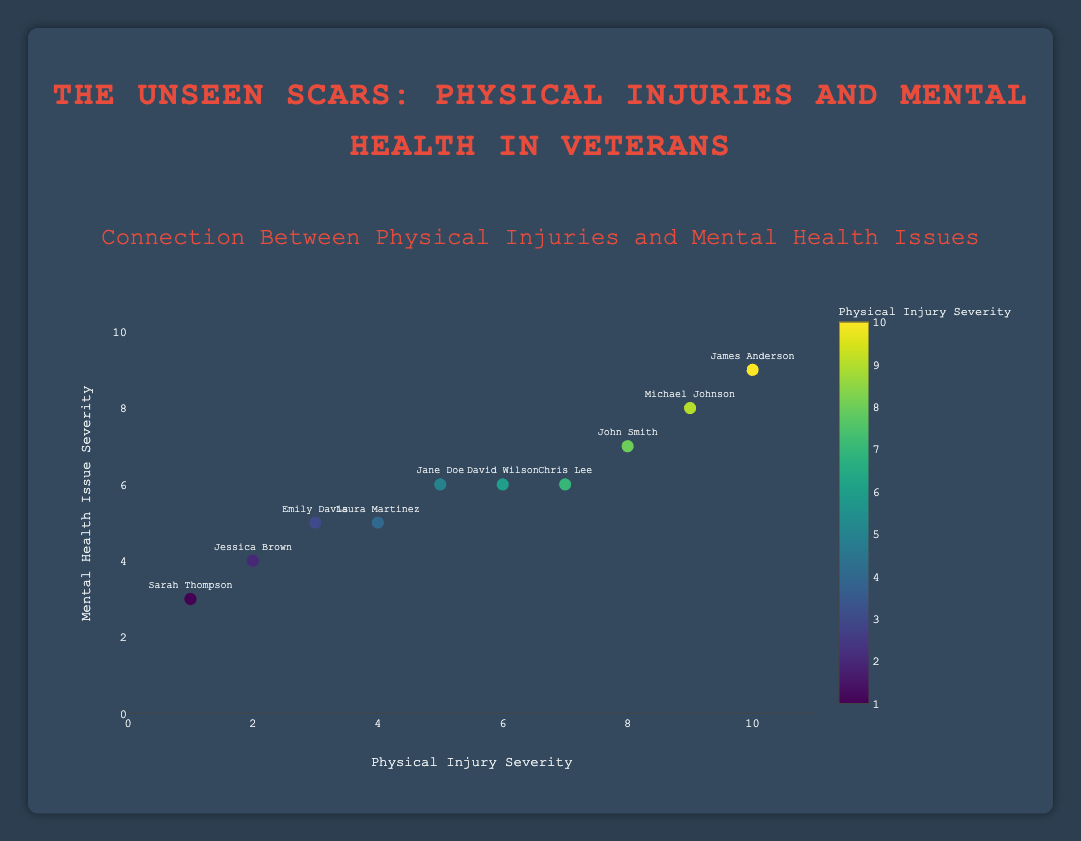How many data points are in the scatter plot? Count all the data points provided in the data. There are 10 data points.
Answer: 10 Which veteran has the highest physical injury severity? Look at the x-axis and find the data point with the highest value. James Anderson has a physical injury severity of 10, which is the highest.
Answer: James Anderson Which veteran has the lowest mental health issue severity? Look at the y-axis and find the data point with the lowest value. Sarah Thompson has a mental health issue severity of 3, which is the lowest.
Answer: Sarah Thompson Is there a general trend between physical injury severity and mental health issue severity? Observe the scatter plot to see if higher physical injury severity correlates with higher mental health issue severity. Yes, there is a general upward trend suggesting that higher physical injury severity is associated with higher mental health issue severity.
Answer: Yes What is the average physical injury severity among the veterans? Add all physical injury severity scores and divide by the number of data points: (8 + 5 + 9 + 3 + 7 + 2 + 6 + 4 + 10 + 1) / 10 = 55 / 10 = 5.5.
Answer: 5.5 Compare the mental health issue severity of John Smith and Jane Doe. Who has a higher severity? Look at the y-axis values for John Smith (7) and Jane Doe (6). John Smith has a higher mental health issue severity.
Answer: John Smith Who has a physical injury severity of 7 and what is their mental health issue severity? Identify the data point where the x-axis value is 7. Chris Lee has a physical injury severity of 7, and his mental health issue severity is 6.
Answer: Chris Lee, 6 What is the range of mental health issue severity among the veterans? Identify the highest and lowest values on the y-axis: highest is 9 (James Anderson), lowest is 3 (Sarah Thompson). The range is 9 - 3 = 6.
Answer: 6 What is the median physical injury severity score? Arrange the physical injury severity scores in order: 1, 2, 3, 4, 5, 6, 7, 8, 9, 10. The median is the middle value in this ordered list, which is 5.5 (average of 5 and 6).
Answer: 5.5 How many veterans have a mental health issue severity greater than 6? Count the number of data points with a y-axis value greater than 6. There are 3 veterans (John Smith, Michael Johnson, and James Anderson).
Answer: 3 